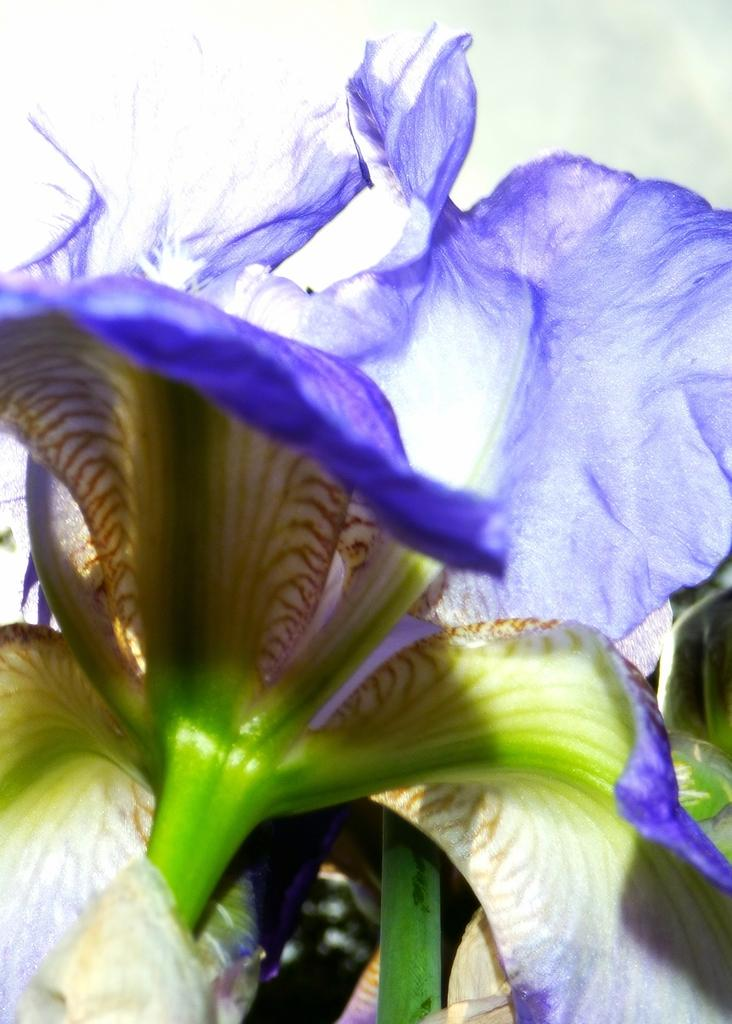What is the main subject of the picture? The main subject of the picture is a flower. What color is the flower? The flower is violet in color. What part of the flower is visible in the image? The stem under the flower is visible in the image. What color is the stem? The stem is green in color. How many teeth can be seen in the picture? There are no teeth visible in the picture; it features a violet flower with a green stem. 